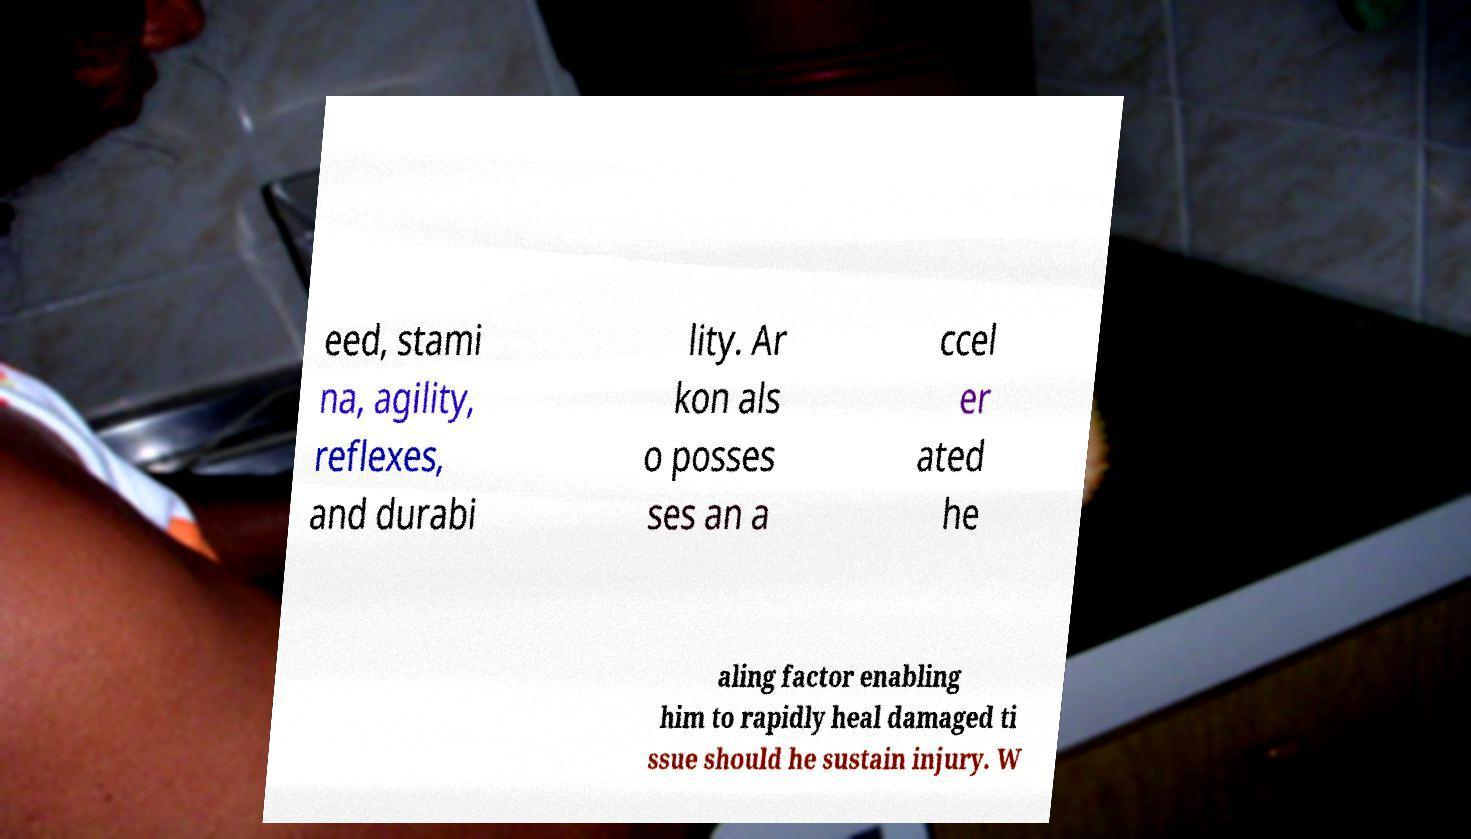There's text embedded in this image that I need extracted. Can you transcribe it verbatim? eed, stami na, agility, reflexes, and durabi lity. Ar kon als o posses ses an a ccel er ated he aling factor enabling him to rapidly heal damaged ti ssue should he sustain injury. W 